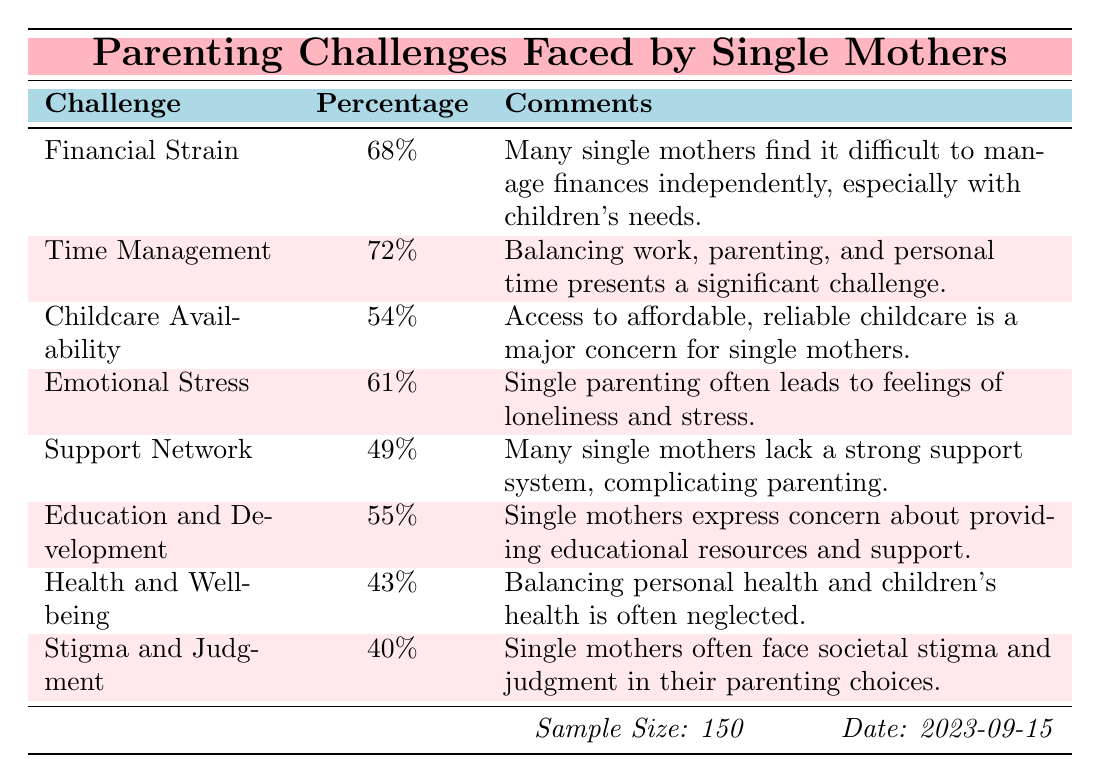What is the percentage of single mothers who face financial strain? The table indicates that 68% of single mothers reported financial strain as a challenge.
Answer: 68% Which parenting challenge has the highest percentage according to the survey? From the table, time management has the highest percentage at 72%.
Answer: 72% Is it true that less than half of the respondents feel they have a strong support network? The table shows that 49% of respondents reported a lack of a strong support network, which is indeed less than half.
Answer: Yes What is the combined percentage of single mothers who face emotional stress and stigma and judgment? Emotional stress is reported at 61% and stigma and judgment at 40%. Combining these, 61 + 40 = 101%.
Answer: 101% What percentage of single mothers reported challenges regarding childcare availability? The table specifies that 54% of single mothers expressed challenges with childcare availability.
Answer: 54% What is the difference in percentage between those who face time management issues and those who face health and well-being challenges? The percentage for time management is 72% and for health and well-being is 43%. The difference is 72 - 43 = 29%.
Answer: 29% How many surveyed challenges have a percentage above 50%? The challenges with percentages above 50% are financial strain (68%), time management (72%), emotional stress (61%), and education and development (55%). This totals to 4 challenges.
Answer: 4 What is the average percentage of the challenges listed in the survey? The percentages are 68, 72, 54, 61, 49, 55, 43, and 40. Summing these gives 442, and dividing by the 8 challenges gives an average of 442 / 8 = 55.25%.
Answer: 55.25% How many challenges have percentages below 50%? The table indicates that health and well-being (43%) and stigma and judgment (40%) are below 50%. Therefore, there are 2 challenges with this characteristic.
Answer: 2 